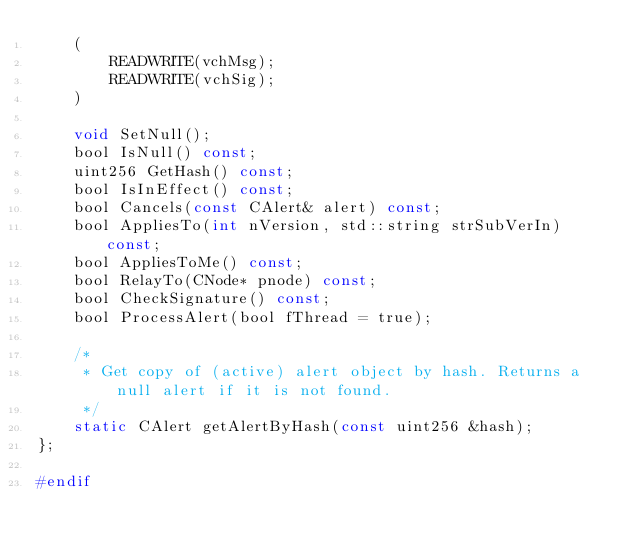<code> <loc_0><loc_0><loc_500><loc_500><_C_>    (
        READWRITE(vchMsg);
        READWRITE(vchSig);
    )

    void SetNull();
    bool IsNull() const;
    uint256 GetHash() const;
    bool IsInEffect() const;
    bool Cancels(const CAlert& alert) const;
    bool AppliesTo(int nVersion, std::string strSubVerIn) const;
    bool AppliesToMe() const;
    bool RelayTo(CNode* pnode) const;
    bool CheckSignature() const;
    bool ProcessAlert(bool fThread = true);

    /*
     * Get copy of (active) alert object by hash. Returns a null alert if it is not found.
     */
    static CAlert getAlertByHash(const uint256 &hash);
};

#endif
</code> 